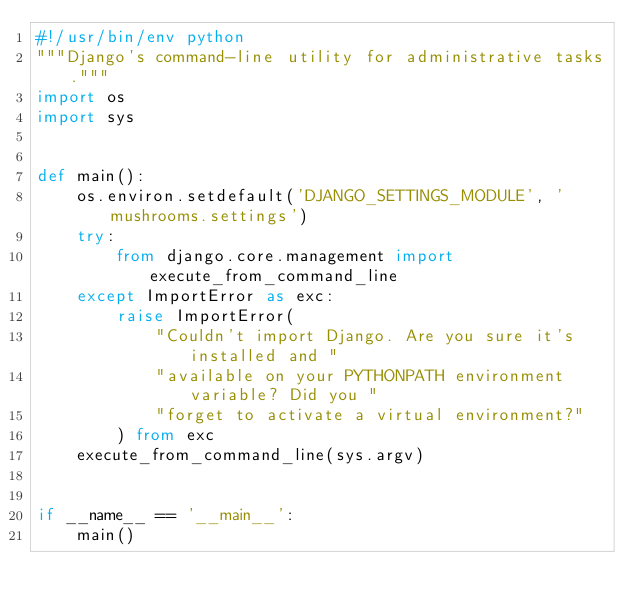Convert code to text. <code><loc_0><loc_0><loc_500><loc_500><_Python_>#!/usr/bin/env python
"""Django's command-line utility for administrative tasks."""
import os
import sys


def main():
    os.environ.setdefault('DJANGO_SETTINGS_MODULE', 'mushrooms.settings')
    try:
        from django.core.management import execute_from_command_line
    except ImportError as exc:
        raise ImportError(
            "Couldn't import Django. Are you sure it's installed and "
            "available on your PYTHONPATH environment variable? Did you "
            "forget to activate a virtual environment?"
        ) from exc
    execute_from_command_line(sys.argv)


if __name__ == '__main__':
    main()
</code> 